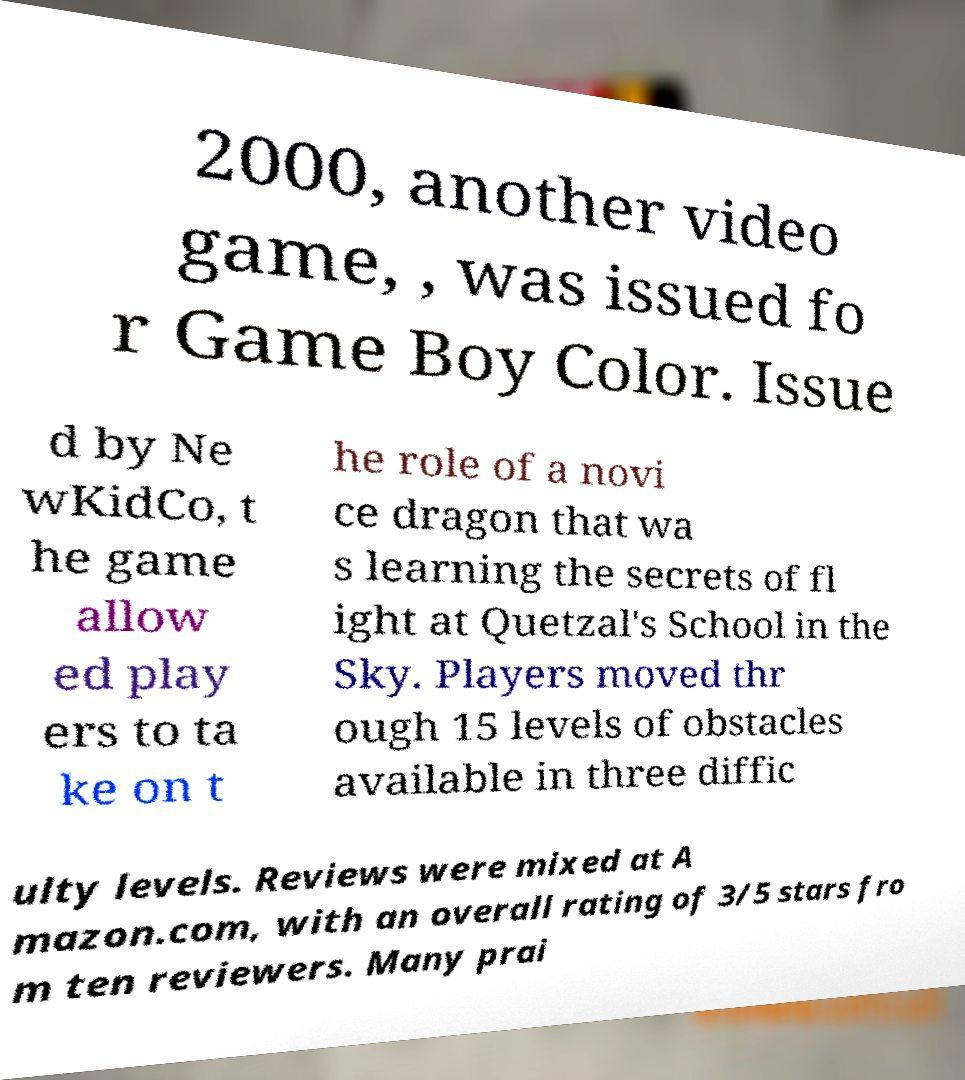Can you accurately transcribe the text from the provided image for me? 2000, another video game, , was issued fo r Game Boy Color. Issue d by Ne wKidCo, t he game allow ed play ers to ta ke on t he role of a novi ce dragon that wa s learning the secrets of fl ight at Quetzal's School in the Sky. Players moved thr ough 15 levels of obstacles available in three diffic ulty levels. Reviews were mixed at A mazon.com, with an overall rating of 3/5 stars fro m ten reviewers. Many prai 